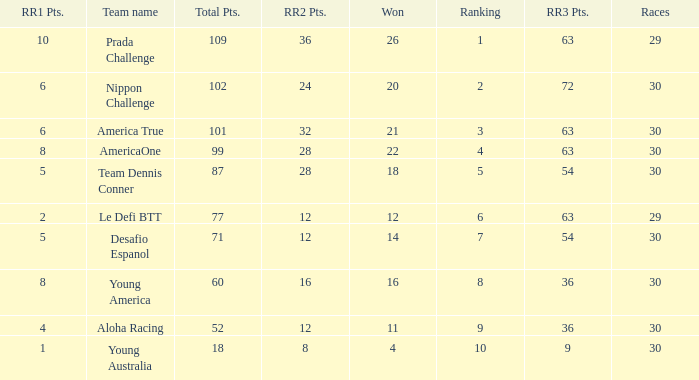Name the total number of rr2 pts for won being 11 1.0. 